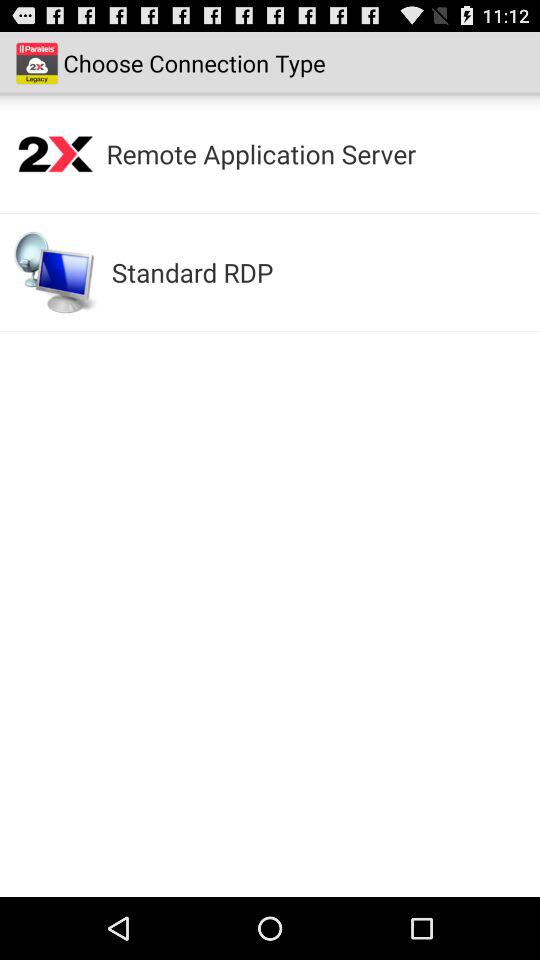What are the types of connections? The types of connections are "Remote Application Server" and "Standard RDP". 